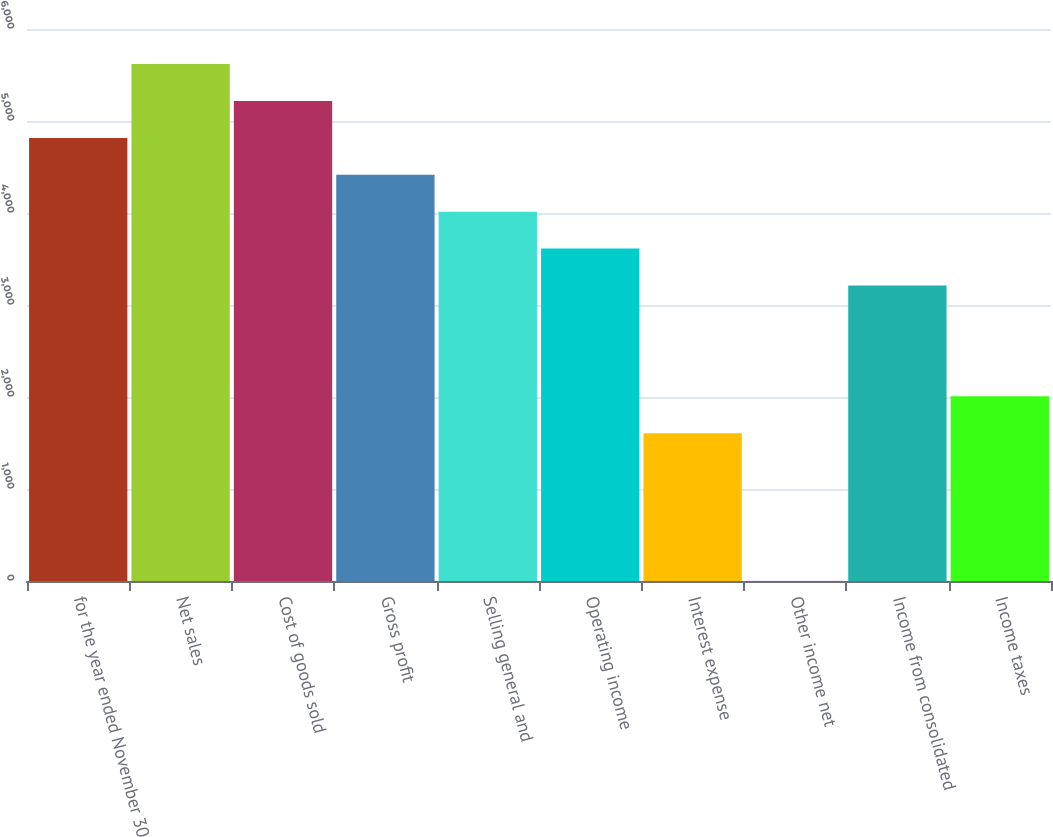<chart> <loc_0><loc_0><loc_500><loc_500><bar_chart><fcel>for the year ended November 30<fcel>Net sales<fcel>Cost of goods sold<fcel>Gross profit<fcel>Selling general and<fcel>Operating income<fcel>Interest expense<fcel>Other income net<fcel>Income from consolidated<fcel>Income taxes<nl><fcel>4816.56<fcel>5618.92<fcel>5217.74<fcel>4415.38<fcel>4014.2<fcel>3613.02<fcel>1607.12<fcel>2.4<fcel>3211.84<fcel>2008.3<nl></chart> 